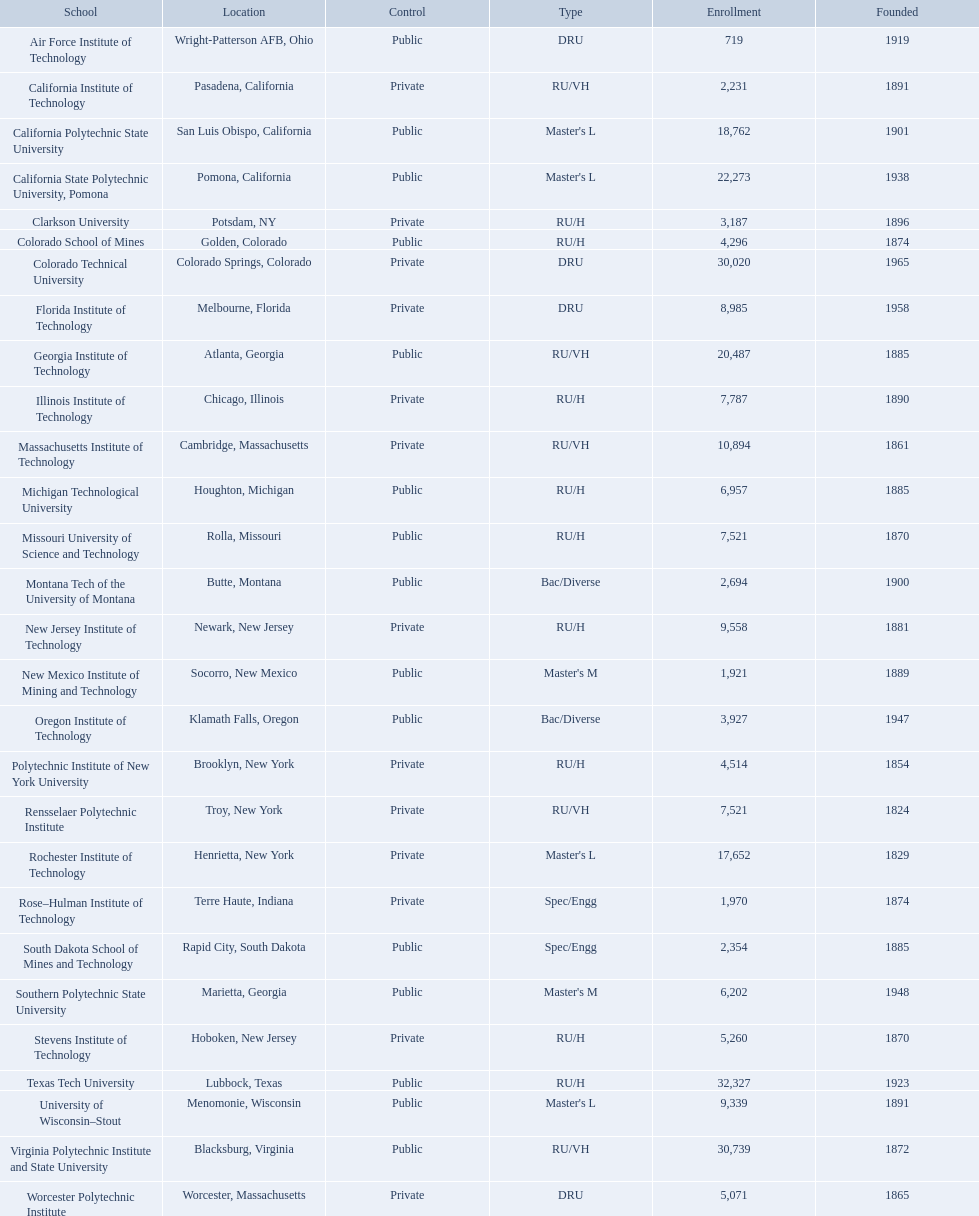What technical universities are in the united states? Air Force Institute of Technology, California Institute of Technology, California Polytechnic State University, California State Polytechnic University, Pomona, Clarkson University, Colorado School of Mines, Colorado Technical University, Florida Institute of Technology, Georgia Institute of Technology, Illinois Institute of Technology, Massachusetts Institute of Technology, Michigan Technological University, Missouri University of Science and Technology, Montana Tech of the University of Montana, New Jersey Institute of Technology, New Mexico Institute of Mining and Technology, Oregon Institute of Technology, Polytechnic Institute of New York University, Rensselaer Polytechnic Institute, Rochester Institute of Technology, Rose–Hulman Institute of Technology, South Dakota School of Mines and Technology, Southern Polytechnic State University, Stevens Institute of Technology, Texas Tech University, University of Wisconsin–Stout, Virginia Polytechnic Institute and State University, Worcester Polytechnic Institute. Which has the highest enrollment? Texas Tech University. What are all the schools? Air Force Institute of Technology, California Institute of Technology, California Polytechnic State University, California State Polytechnic University, Pomona, Clarkson University, Colorado School of Mines, Colorado Technical University, Florida Institute of Technology, Georgia Institute of Technology, Illinois Institute of Technology, Massachusetts Institute of Technology, Michigan Technological University, Missouri University of Science and Technology, Montana Tech of the University of Montana, New Jersey Institute of Technology, New Mexico Institute of Mining and Technology, Oregon Institute of Technology, Polytechnic Institute of New York University, Rensselaer Polytechnic Institute, Rochester Institute of Technology, Rose–Hulman Institute of Technology, South Dakota School of Mines and Technology, Southern Polytechnic State University, Stevens Institute of Technology, Texas Tech University, University of Wisconsin–Stout, Virginia Polytechnic Institute and State University, Worcester Polytechnic Institute. What is the enrollment of each school? 719, 2,231, 18,762, 22,273, 3,187, 4,296, 30,020, 8,985, 20,487, 7,787, 10,894, 6,957, 7,521, 2,694, 9,558, 1,921, 3,927, 4,514, 7,521, 17,652, 1,970, 2,354, 6,202, 5,260, 32,327, 9,339, 30,739, 5,071. And which school had the highest enrollment? Texas Tech University. 